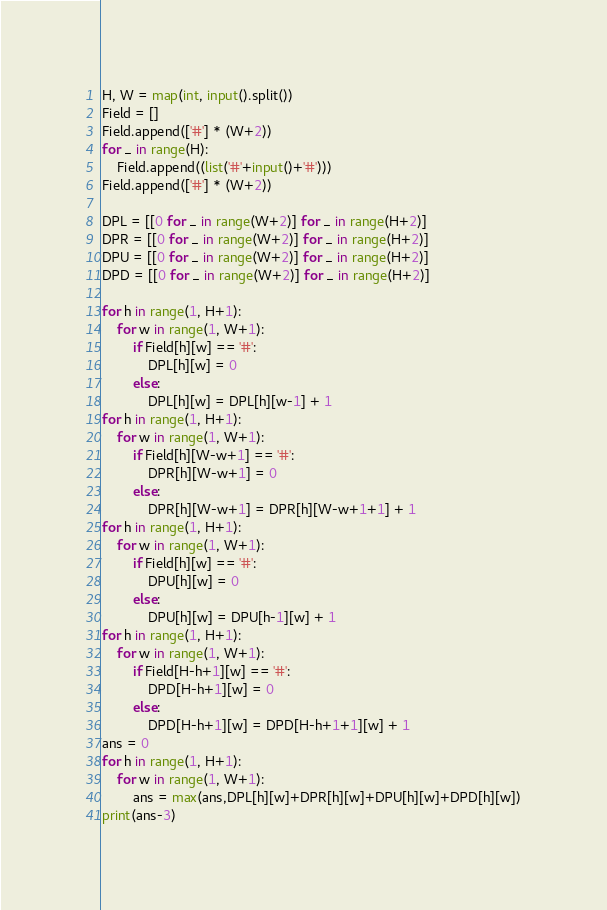<code> <loc_0><loc_0><loc_500><loc_500><_Python_>H, W = map(int, input().split())
Field = []
Field.append(['#'] * (W+2))
for _ in range(H):
    Field.append((list('#'+input()+'#')))
Field.append(['#'] * (W+2))

DPL = [[0 for _ in range(W+2)] for _ in range(H+2)]
DPR = [[0 for _ in range(W+2)] for _ in range(H+2)]
DPU = [[0 for _ in range(W+2)] for _ in range(H+2)]
DPD = [[0 for _ in range(W+2)] for _ in range(H+2)]

for h in range(1, H+1):
    for w in range(1, W+1):
        if Field[h][w] == '#':
            DPL[h][w] = 0
        else:
            DPL[h][w] = DPL[h][w-1] + 1
for h in range(1, H+1):
    for w in range(1, W+1):
        if Field[h][W-w+1] == '#':
            DPR[h][W-w+1] = 0
        else:
            DPR[h][W-w+1] = DPR[h][W-w+1+1] + 1
for h in range(1, H+1):
    for w in range(1, W+1):
        if Field[h][w] == '#':
            DPU[h][w] = 0
        else:
            DPU[h][w] = DPU[h-1][w] + 1   
for h in range(1, H+1):
    for w in range(1, W+1):
        if Field[H-h+1][w] == '#':
            DPD[H-h+1][w] = 0
        else:
            DPD[H-h+1][w] = DPD[H-h+1+1][w] + 1 
ans = 0          
for h in range(1, H+1):
    for w in range(1, W+1):
        ans = max(ans,DPL[h][w]+DPR[h][w]+DPU[h][w]+DPD[h][w])
print(ans-3)</code> 